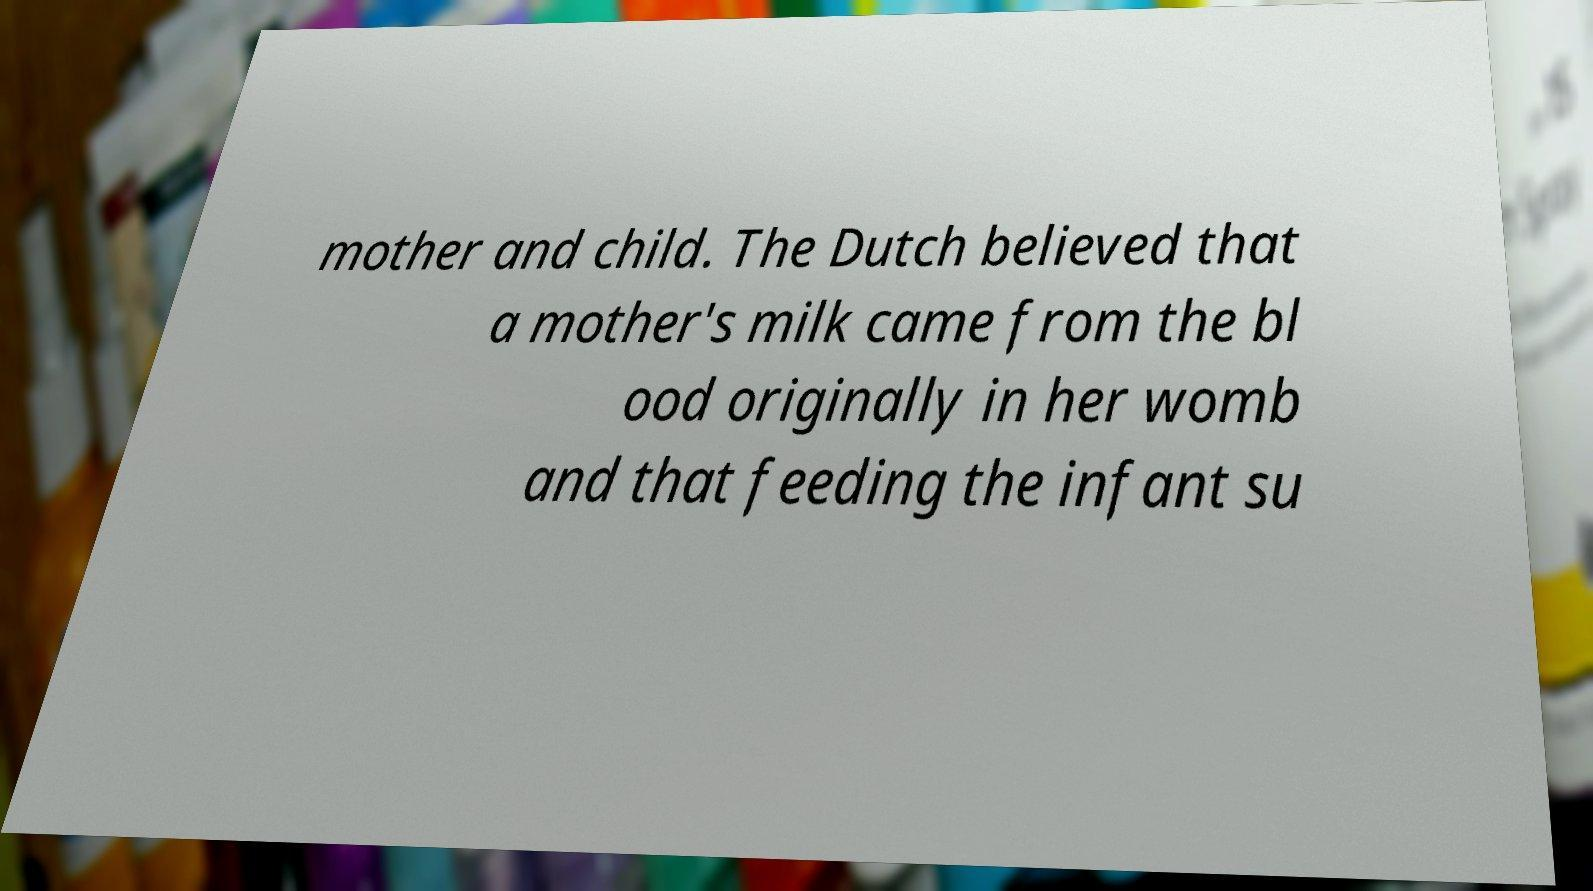Please read and relay the text visible in this image. What does it say? mother and child. The Dutch believed that a mother's milk came from the bl ood originally in her womb and that feeding the infant su 